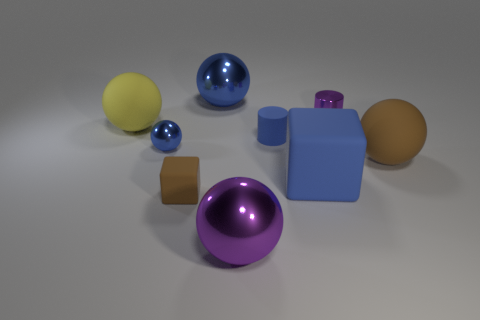Subtract all small metallic spheres. How many spheres are left? 4 Subtract all purple spheres. How many spheres are left? 4 Subtract 2 balls. How many balls are left? 3 Subtract all yellow balls. Subtract all red cylinders. How many balls are left? 4 Add 1 tiny brown matte balls. How many objects exist? 10 Subtract 0 green cubes. How many objects are left? 9 Subtract all spheres. How many objects are left? 4 Subtract all yellow matte cubes. Subtract all yellow matte spheres. How many objects are left? 8 Add 1 small purple objects. How many small purple objects are left? 2 Add 5 yellow matte things. How many yellow matte things exist? 6 